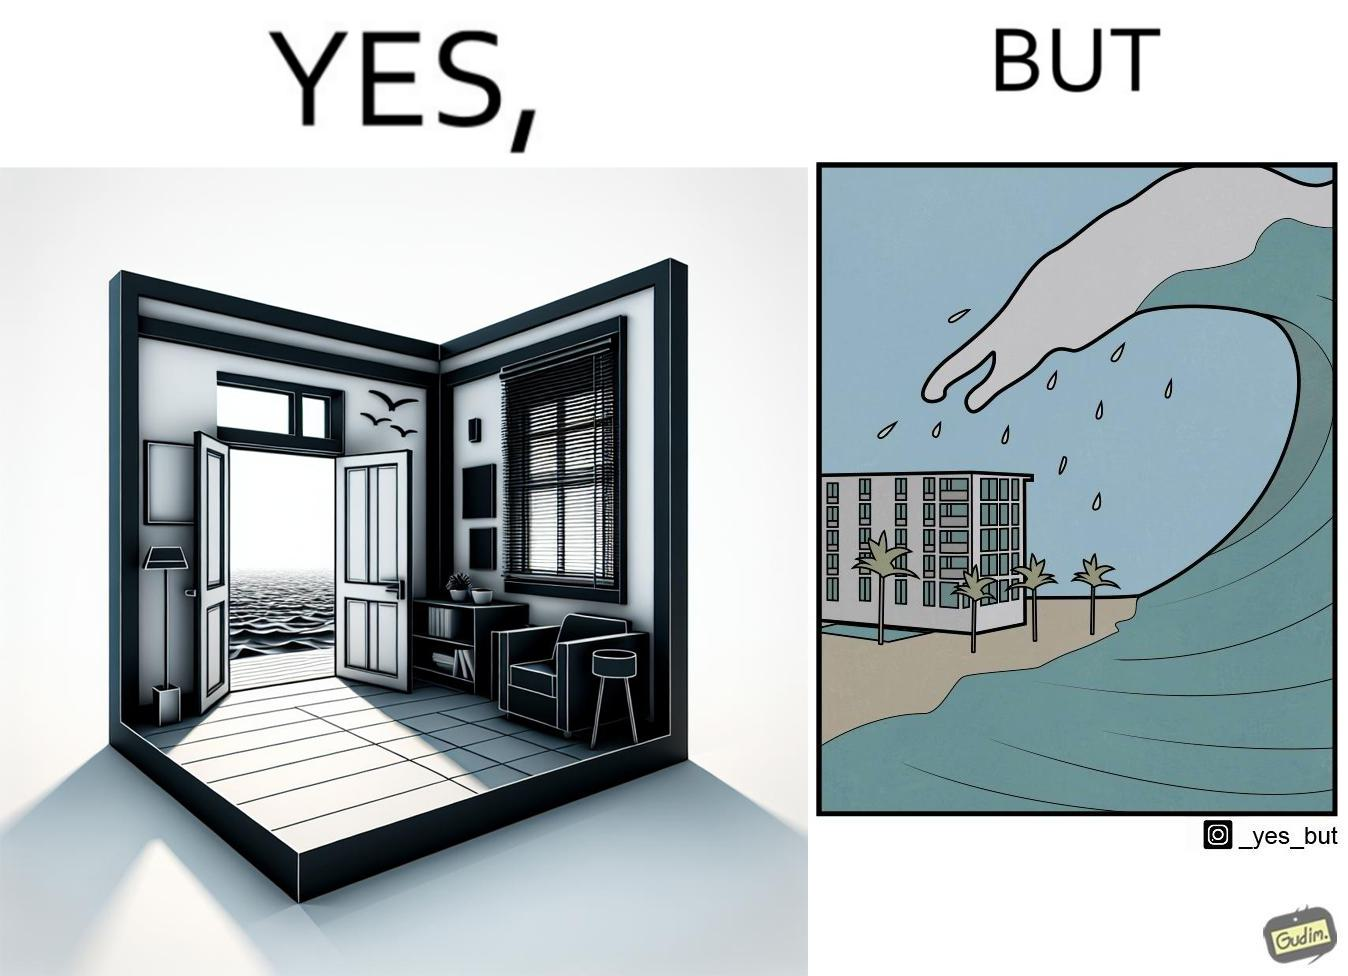What is shown in the left half versus the right half of this image? In the left part of the image: a room with a sea-facing door In the right part of the image: high waves in the sea twice of the height of the building near the sea 